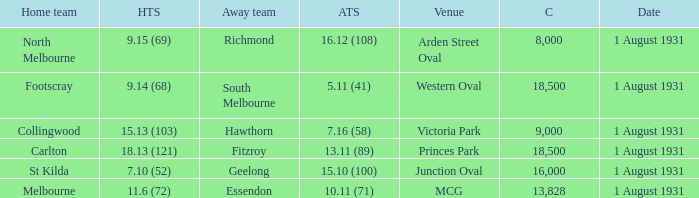What is the home teams score at Victoria Park? 15.13 (103). 